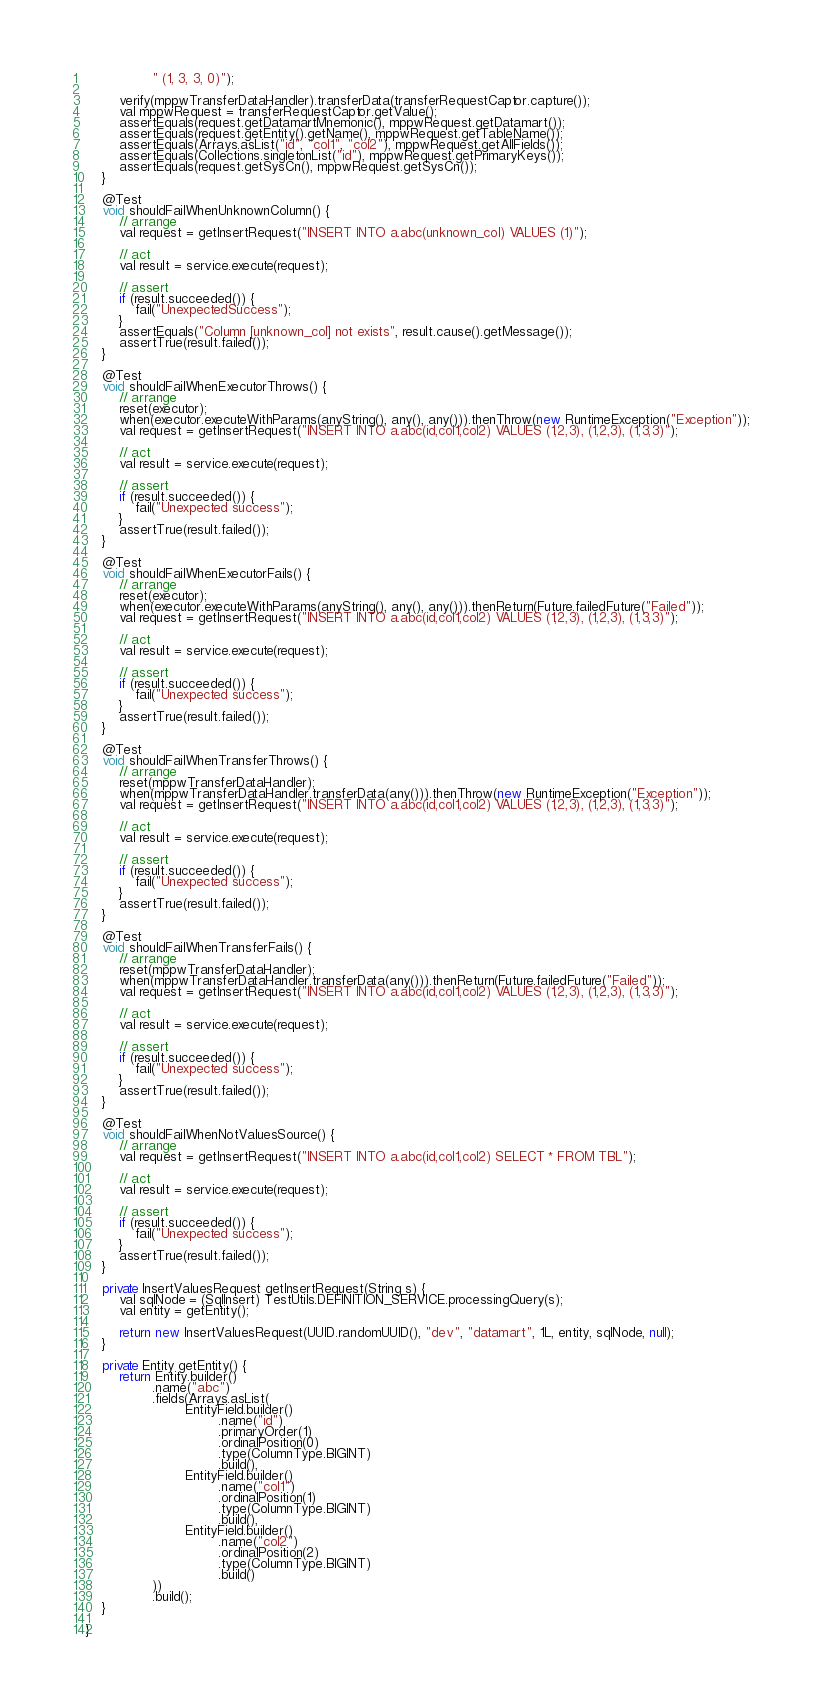Convert code to text. <code><loc_0><loc_0><loc_500><loc_500><_Java_>                " (1, 3, 3, 0)");

        verify(mppwTransferDataHandler).transferData(transferRequestCaptor.capture());
        val mppwRequest = transferRequestCaptor.getValue();
        assertEquals(request.getDatamartMnemonic(), mppwRequest.getDatamart());
        assertEquals(request.getEntity().getName(), mppwRequest.getTableName());
        assertEquals(Arrays.asList("id", "col1", "col2"), mppwRequest.getAllFields());
        assertEquals(Collections.singletonList("id"), mppwRequest.getPrimaryKeys());
        assertEquals(request.getSysCn(), mppwRequest.getSysCn());
    }

    @Test
    void shouldFailWhenUnknownColumn() {
        // arrange
        val request = getInsertRequest("INSERT INTO a.abc(unknown_col) VALUES (1)");

        // act
        val result = service.execute(request);

        // assert
        if (result.succeeded()) {
            fail("UnexpectedSuccess");
        }
        assertEquals("Column [unknown_col] not exists", result.cause().getMessage());
        assertTrue(result.failed());
    }

    @Test
    void shouldFailWhenExecutorThrows() {
        // arrange
        reset(executor);
        when(executor.executeWithParams(anyString(), any(), any())).thenThrow(new RuntimeException("Exception"));
        val request = getInsertRequest("INSERT INTO a.abc(id,col1,col2) VALUES (1,2,3), (1,2,3), (1,3,3)");

        // act
        val result = service.execute(request);

        // assert
        if (result.succeeded()) {
            fail("Unexpected success");
        }
        assertTrue(result.failed());
    }

    @Test
    void shouldFailWhenExecutorFails() {
        // arrange
        reset(executor);
        when(executor.executeWithParams(anyString(), any(), any())).thenReturn(Future.failedFuture("Failed"));
        val request = getInsertRequest("INSERT INTO a.abc(id,col1,col2) VALUES (1,2,3), (1,2,3), (1,3,3)");

        // act
        val result = service.execute(request);

        // assert
        if (result.succeeded()) {
            fail("Unexpected success");
        }
        assertTrue(result.failed());
    }

    @Test
    void shouldFailWhenTransferThrows() {
        // arrange
        reset(mppwTransferDataHandler);
        when(mppwTransferDataHandler.transferData(any())).thenThrow(new RuntimeException("Exception"));
        val request = getInsertRequest("INSERT INTO a.abc(id,col1,col2) VALUES (1,2,3), (1,2,3), (1,3,3)");

        // act
        val result = service.execute(request);

        // assert
        if (result.succeeded()) {
            fail("Unexpected success");
        }
        assertTrue(result.failed());
    }

    @Test
    void shouldFailWhenTransferFails() {
        // arrange
        reset(mppwTransferDataHandler);
        when(mppwTransferDataHandler.transferData(any())).thenReturn(Future.failedFuture("Failed"));
        val request = getInsertRequest("INSERT INTO a.abc(id,col1,col2) VALUES (1,2,3), (1,2,3), (1,3,3)");

        // act
        val result = service.execute(request);

        // assert
        if (result.succeeded()) {
            fail("Unexpected success");
        }
        assertTrue(result.failed());
    }

    @Test
    void shouldFailWhenNotValuesSource() {
        // arrange
        val request = getInsertRequest("INSERT INTO a.abc(id,col1,col2) SELECT * FROM TBL");

        // act
        val result = service.execute(request);

        // assert
        if (result.succeeded()) {
            fail("Unexpected success");
        }
        assertTrue(result.failed());
    }

    private InsertValuesRequest getInsertRequest(String s) {
        val sqlNode = (SqlInsert) TestUtils.DEFINITION_SERVICE.processingQuery(s);
        val entity = getEntity();

        return new InsertValuesRequest(UUID.randomUUID(), "dev", "datamart", 1L, entity, sqlNode, null);
    }

    private Entity getEntity() {
        return Entity.builder()
                .name("abc")
                .fields(Arrays.asList(
                        EntityField.builder()
                                .name("id")
                                .primaryOrder(1)
                                .ordinalPosition(0)
                                .type(ColumnType.BIGINT)
                                .build(),
                        EntityField.builder()
                                .name("col1")
                                .ordinalPosition(1)
                                .type(ColumnType.BIGINT)
                                .build(),
                        EntityField.builder()
                                .name("col2")
                                .ordinalPosition(2)
                                .type(ColumnType.BIGINT)
                                .build()
                ))
                .build();
    }

}</code> 